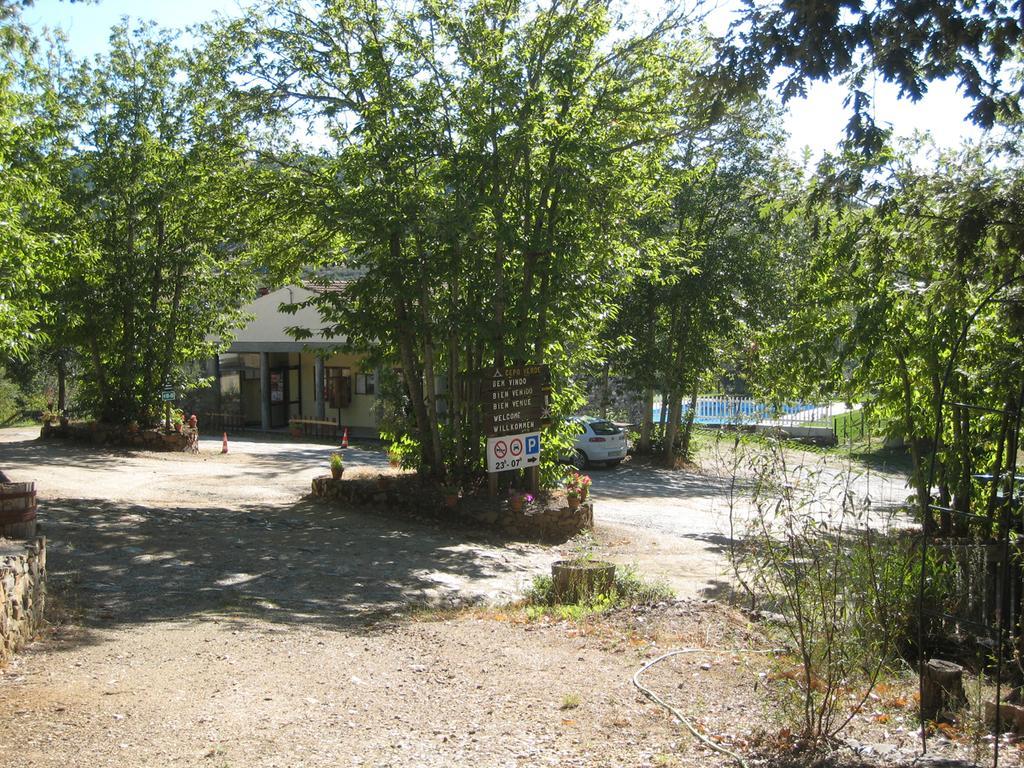Please provide a concise description of this image. In this image we can see a house. There are many trees and plants in the image. We can see the sky in the image. There are few boards in the image. We can see a bridge at the right side of the image. There are few road safety cones in the image. 